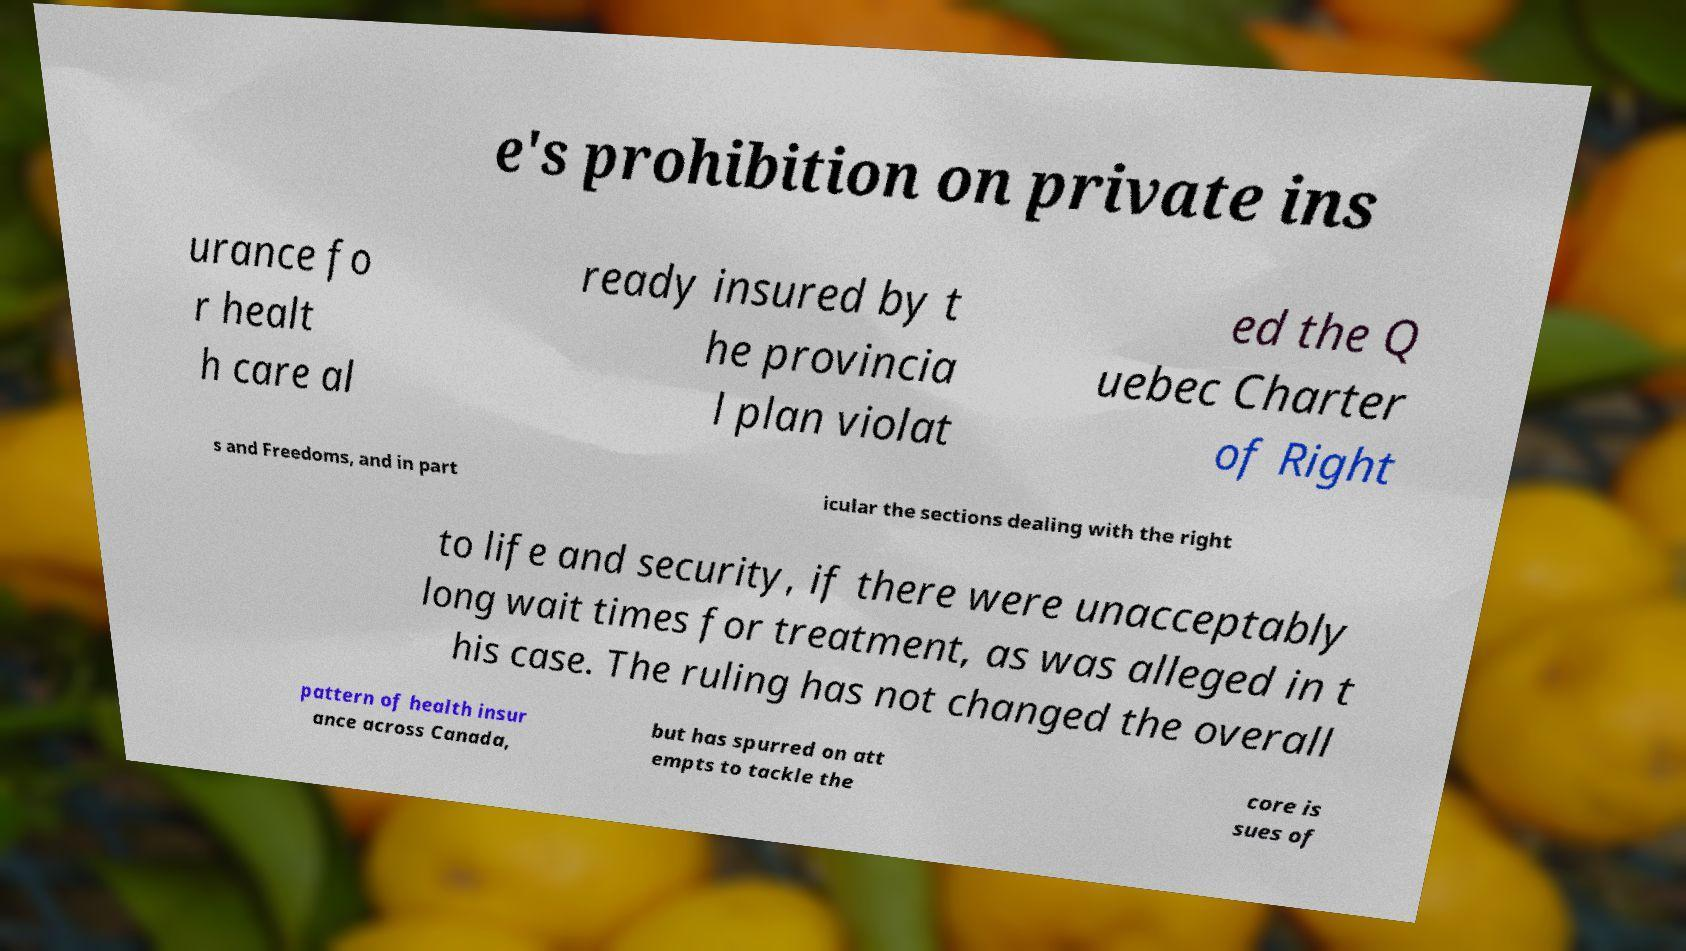Please identify and transcribe the text found in this image. e's prohibition on private ins urance fo r healt h care al ready insured by t he provincia l plan violat ed the Q uebec Charter of Right s and Freedoms, and in part icular the sections dealing with the right to life and security, if there were unacceptably long wait times for treatment, as was alleged in t his case. The ruling has not changed the overall pattern of health insur ance across Canada, but has spurred on att empts to tackle the core is sues of 